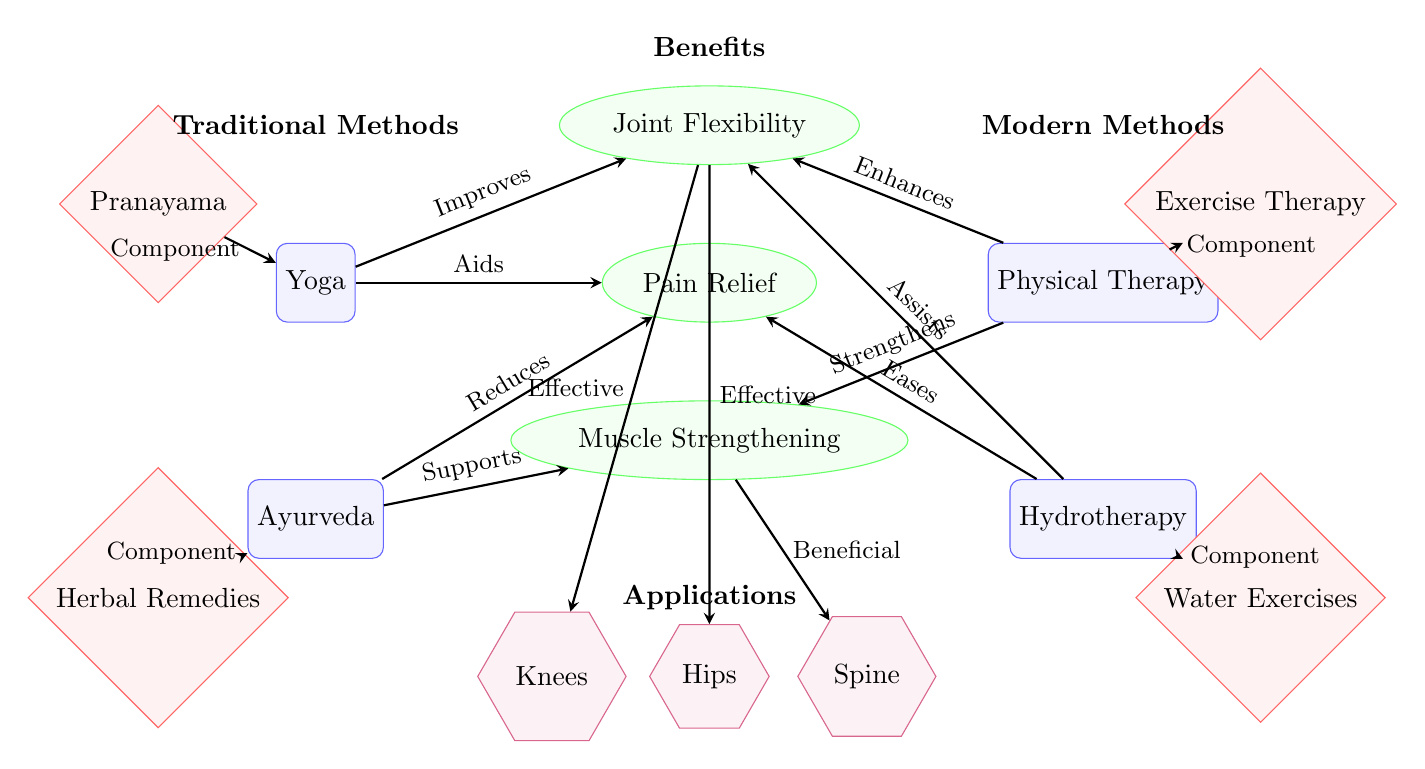What traditional method is used for joint flexibility? The diagram indicates that Yoga is a traditional method that improves joint flexibility. This is shown by the arrow connecting Yoga to the Joint Flexibility benefit.
Answer: Yoga Which modern method is associated with water-based exercises? The diagram shows Hydrotherapy as the modern method that includes water exercises, indicated by the arrow connecting Hydrotherapy to the Water Exercises mechanism.
Answer: Hydrotherapy How many benefits are listed in the diagram? The diagram lists three benefits: Joint Flexibility, Pain Relief, and Muscle Strengthening. These can be counted as distinct nodes in the Benefits section.
Answer: 3 What component of Ayurveda helps in pain relief? The connection from Ayurveda to Herbal Remedies in the diagram suggests that Herbal Remedies are a component of Ayurveda that aids in pain relief.
Answer: Herbal Remedies Which method enhances joint flexibility using exercise therapy? The diagram shows that Physical Therapy enhances joint flexibility, as indicated by the arrow from Physical Therapy to the Joint Flexibility benefit, with Exercise Therapy as its mechanism.
Answer: Physical Therapy What benefit does Ayurveda provide for muscle strengthening? The diagram indicates that Ayurveda supports Muscle Strengthening, with an arrow directed from Ayurveda to the Muscle Strengthening benefit, implying this supportive role.
Answer: Supports Which area of application is associated with both traditional and modern methods? The diagram highlights Knees as an area of application for both traditional methods (Yoga and Ayurveda) and modern methods (Physical Therapy and Hydrotherapy) indicated by the effective benefits leading to the respective application.
Answer: Knees What mechanism is unique to traditional methods in this diagram? The mechanisms Pranayama and Herbal Remedies are shown specifically connected to traditional methods of Yoga and Ayurveda respectively, making them unique to this category.
Answer: Pranayama Which modern method eases pain relief according to the diagram? The diagram clearly depicts that Hydrotherapy eases Pain Relief, shown by the arrow from Hydrotherapy to the Pain Relief benefit.
Answer: Hydrotherapy 